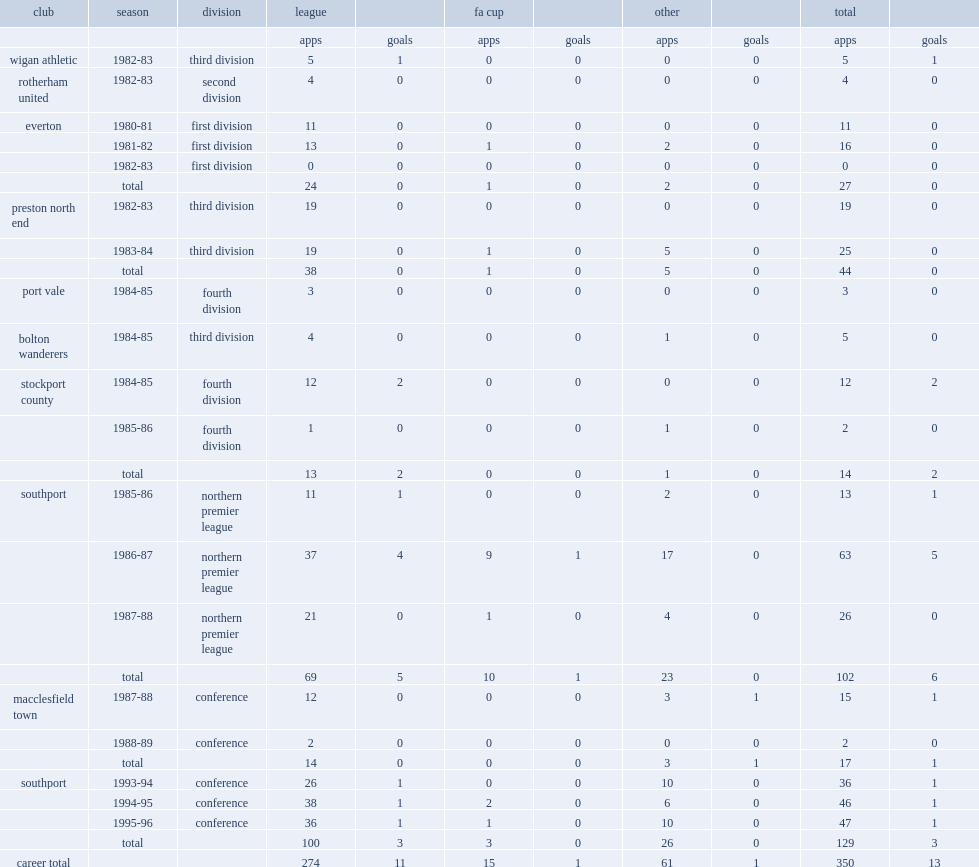Which club did lodge play for in 1980-81. Everton. 